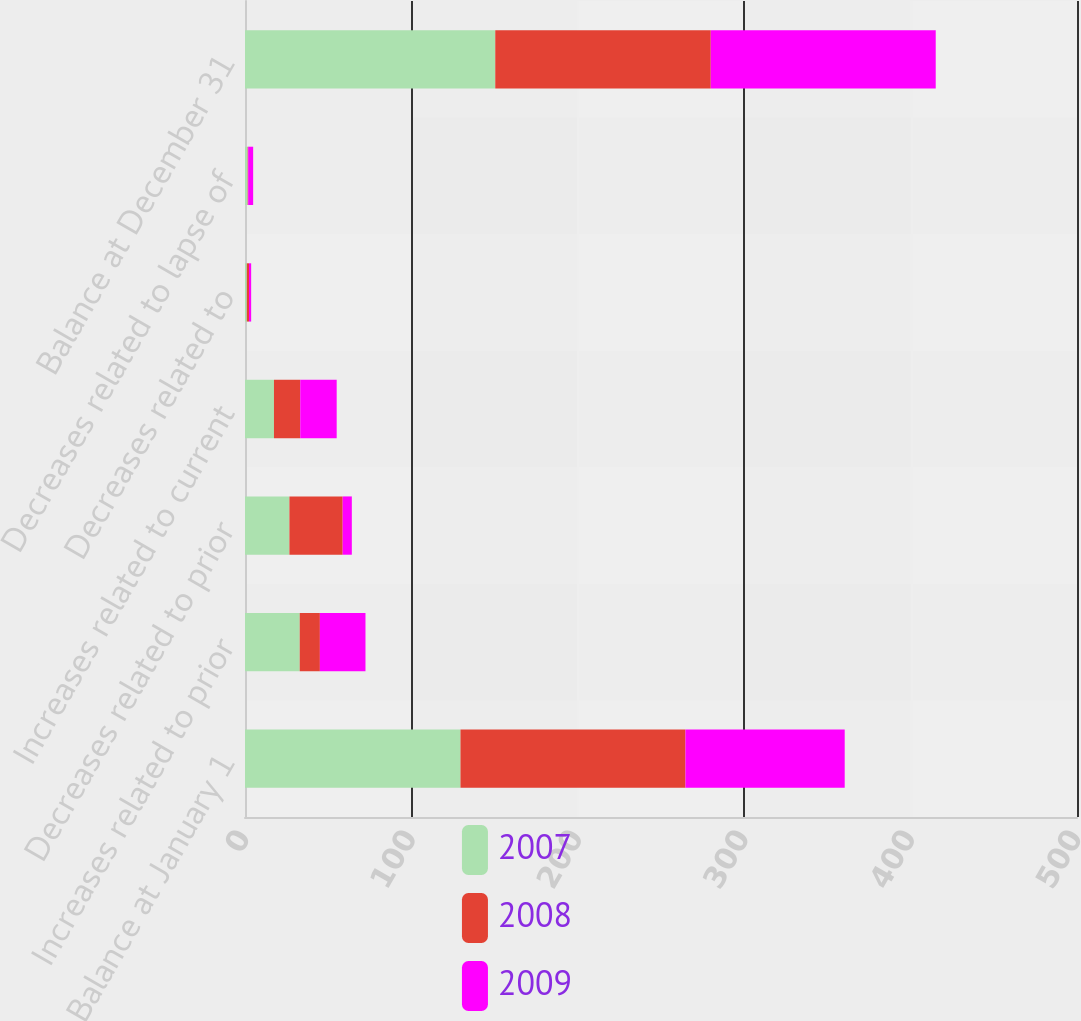<chart> <loc_0><loc_0><loc_500><loc_500><stacked_bar_chart><ecel><fcel>Balance at January 1<fcel>Increases related to prior<fcel>Decreases related to prior<fcel>Increases related to current<fcel>Decreases related to<fcel>Decreases related to lapse of<fcel>Balance at December 31<nl><fcel>2007<fcel>129.5<fcel>32.9<fcel>26.7<fcel>17.4<fcel>1.1<fcel>1.6<fcel>150.4<nl><fcel>2008<fcel>135.2<fcel>12.1<fcel>32<fcel>15.8<fcel>1.3<fcel>0.3<fcel>129.5<nl><fcel>2009<fcel>95.7<fcel>27.4<fcel>5.5<fcel>21.9<fcel>1.3<fcel>3<fcel>135.2<nl></chart> 